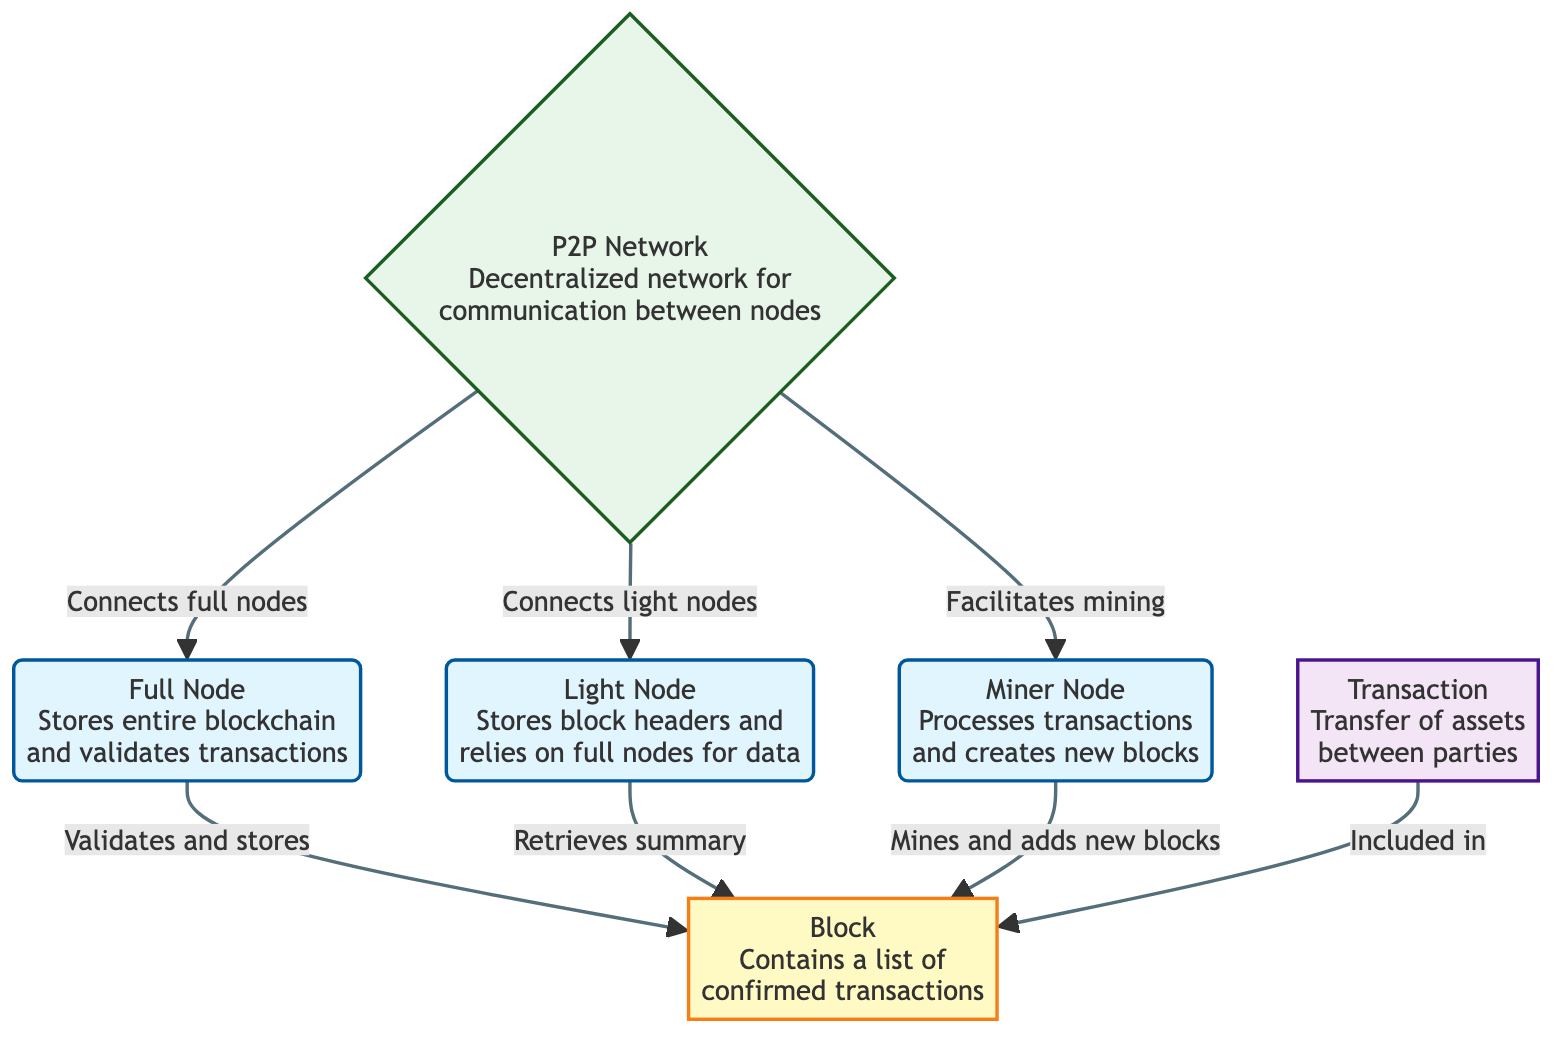What type of node stores the entire blockchain? According to the diagram, the Full Node is described as storing the entire blockchain and validating transactions.
Answer: Full Node What does a Light Node rely on for data? The diagram indicates that a Light Node stores block headers and relies on Full Nodes for data.
Answer: Full Nodes How many types of nodes are shown in the diagram? There are three types of nodes displayed: Full Node, Light Node, and Miner Node.
Answer: Three What is included in a Block? The diagram states that a Block contains a list of confirmed transactions.
Answer: Confirmed transactions Which component processes transactions and creates new blocks? The diagram clearly indicates that the Miner Node is responsible for processing transactions and creating new blocks.
Answer: Miner Node What facilitates communication between nodes in the blockchain? The diagram illustrates that the P2P Network facilitates communication between nodes.
Answer: P2P Network How does a Light Node retrieve information about a Block? The diagram shows that a Light Node retrieves a summary of a Block, indicating its role in the network.
Answer: Retrieves summary What is the primary function of a transaction in the blockchain? According to the diagram, the primary function of a transaction is the transfer of assets between parties.
Answer: Transfer of assets What connects both Full Nodes and Light Nodes? The diagram depicts that the P2P Network connects Full Nodes and Light Nodes within the blockchain ecosystem.
Answer: P2P Network How does the Miner Node interact with a Block? The diagram specifies that the Miner Node mines and adds new blocks, indicating its active role in block creation.
Answer: Mines and adds new blocks What color represents the Block in the diagram? The diagram uses a specific fill color, described as #fff9c4, to visually represent the Block component.
Answer: #fff9c4 